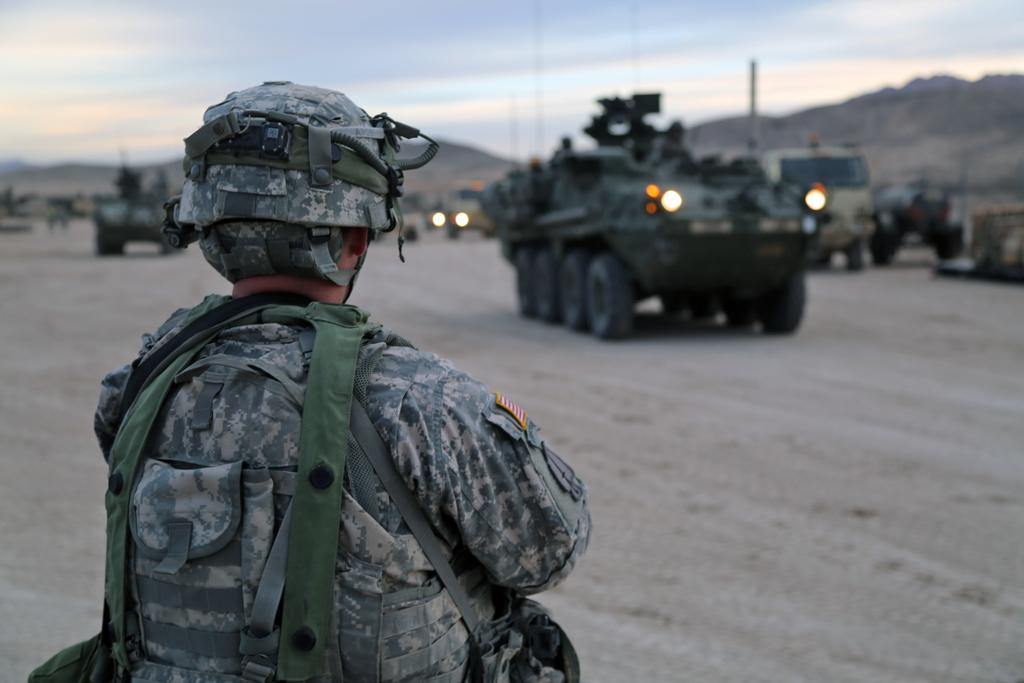Who is present in the image? There is a man in the image. What is the man wearing on his head? The man is wearing a helmet. What can be seen in the background of the image? There are vehicles in the background of the image. What type of frame is the man holding in the image? There is no frame present in the image; the man is wearing a helmet. 